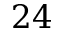<formula> <loc_0><loc_0><loc_500><loc_500>2 4</formula> 